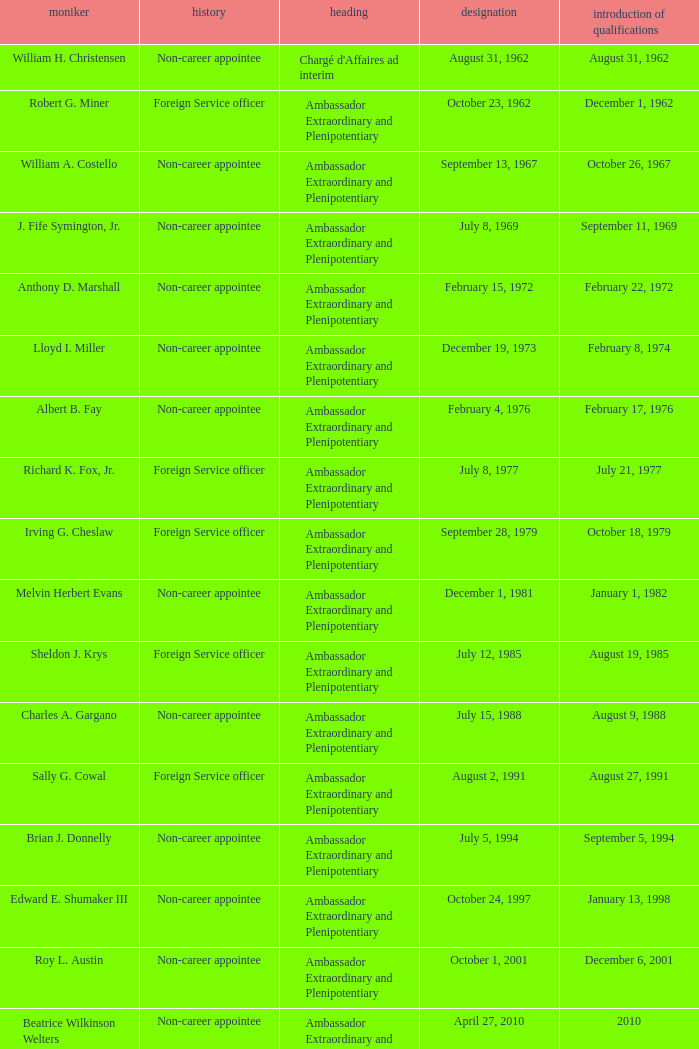Who presented their credentials at an unknown date? Margaret B. Diop. 